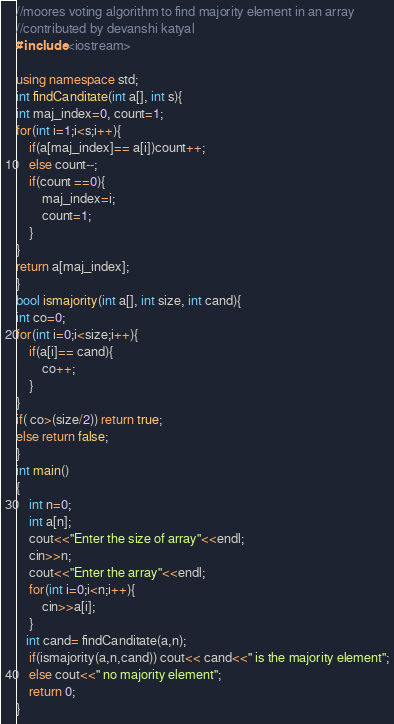<code> <loc_0><loc_0><loc_500><loc_500><_C++_>//moores voting algorithm to find majority element in an array
//contributed by devanshi katyal
#include <iostream>

using namespace std;
int findCanditate(int a[], int s){
int maj_index=0, count=1;
for(int i=1;i<s;i++){
    if(a[maj_index]== a[i])count++;
    else count--;
    if(count ==0){
        maj_index=i;
        count=1;
    }
}
return a[maj_index];
}
bool ismajority(int a[], int size, int cand){
int co=0;
for(int i=0;i<size;i++){
    if(a[i]== cand){
        co++;
    }
}
if( co>(size/2)) return true;
else return false;
}
int main()
{
    int n=0;
    int a[n];
    cout<<"Enter the size of array"<<endl;
    cin>>n;
    cout<<"Enter the array"<<endl;
    for(int i=0;i<n;i++){
        cin>>a[i];
    }
   int cand= findCanditate(a,n);
    if(ismajority(a,n,cand)) cout<< cand<<" is the majority element";
    else cout<<" no majority element";
    return 0;
}
</code> 